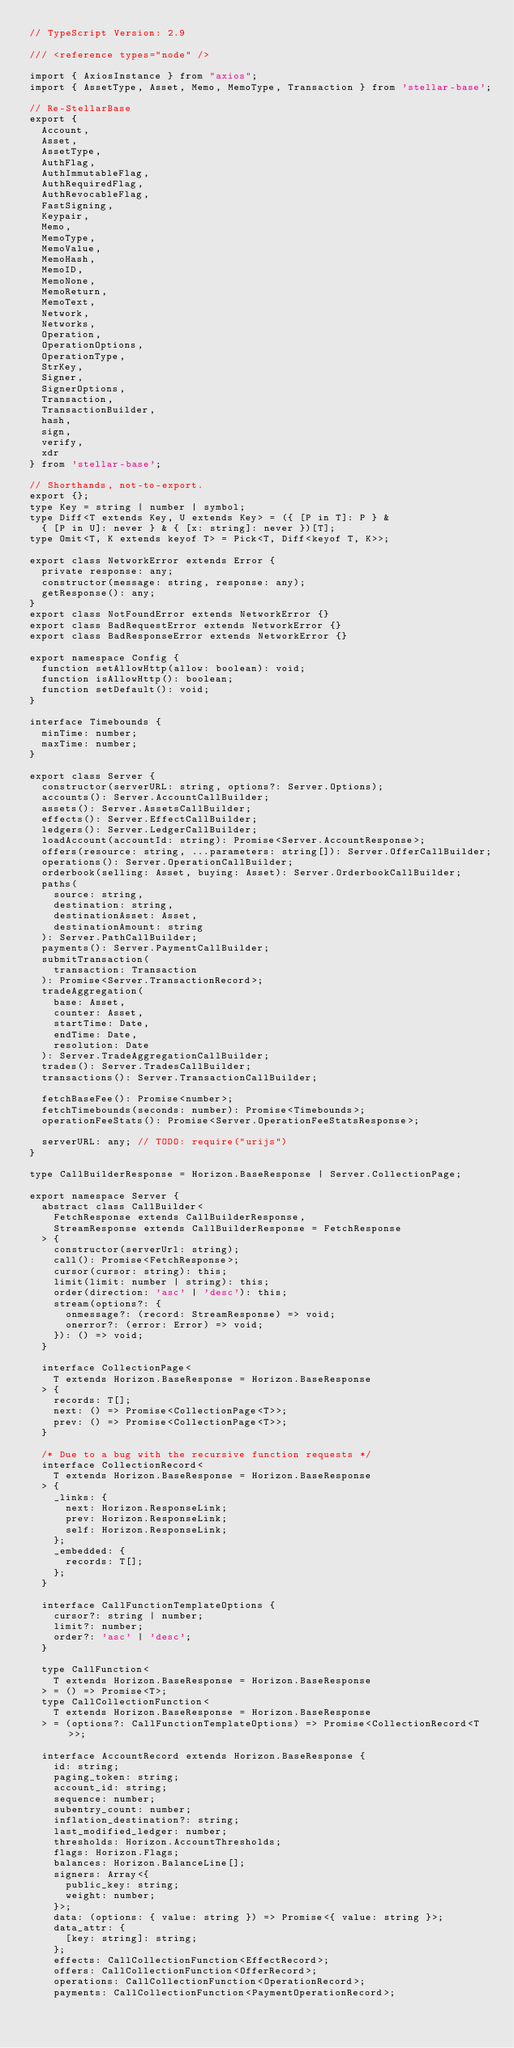Convert code to text. <code><loc_0><loc_0><loc_500><loc_500><_TypeScript_>// TypeScript Version: 2.9

/// <reference types="node" />

import { AxiosInstance } from "axios";
import { AssetType, Asset, Memo, MemoType, Transaction } from 'stellar-base';

// Re-StellarBase
export {
  Account,
  Asset,
  AssetType,
  AuthFlag,
  AuthImmutableFlag,
  AuthRequiredFlag,
  AuthRevocableFlag,
  FastSigning,
  Keypair,
  Memo,
  MemoType,
  MemoValue,
  MemoHash,
  MemoID,
  MemoNone,
  MemoReturn,
  MemoText,
  Network,
  Networks,
  Operation,
  OperationOptions,
  OperationType,
  StrKey,
  Signer,
  SignerOptions,
  Transaction,
  TransactionBuilder,
  hash,
  sign,
  verify,
  xdr
} from 'stellar-base';

// Shorthands, not-to-export.
export {};
type Key = string | number | symbol;
type Diff<T extends Key, U extends Key> = ({ [P in T]: P } &
  { [P in U]: never } & { [x: string]: never })[T];
type Omit<T, K extends keyof T> = Pick<T, Diff<keyof T, K>>;

export class NetworkError extends Error {
  private response: any;
  constructor(message: string, response: any);
  getResponse(): any;
}
export class NotFoundError extends NetworkError {}
export class BadRequestError extends NetworkError {}
export class BadResponseError extends NetworkError {}

export namespace Config {
  function setAllowHttp(allow: boolean): void;
  function isAllowHttp(): boolean;
  function setDefault(): void;
}

interface Timebounds {
  minTime: number;
  maxTime: number;
}

export class Server {
  constructor(serverURL: string, options?: Server.Options);
  accounts(): Server.AccountCallBuilder;
  assets(): Server.AssetsCallBuilder;
  effects(): Server.EffectCallBuilder;
  ledgers(): Server.LedgerCallBuilder;
  loadAccount(accountId: string): Promise<Server.AccountResponse>;
  offers(resource: string, ...parameters: string[]): Server.OfferCallBuilder;
  operations(): Server.OperationCallBuilder;
  orderbook(selling: Asset, buying: Asset): Server.OrderbookCallBuilder;
  paths(
    source: string,
    destination: string,
    destinationAsset: Asset,
    destinationAmount: string
  ): Server.PathCallBuilder;
  payments(): Server.PaymentCallBuilder;
  submitTransaction(
    transaction: Transaction
  ): Promise<Server.TransactionRecord>;
  tradeAggregation(
    base: Asset,
    counter: Asset,
    startTime: Date,
    endTime: Date,
    resolution: Date
  ): Server.TradeAggregationCallBuilder;
  trades(): Server.TradesCallBuilder;
  transactions(): Server.TransactionCallBuilder;

  fetchBaseFee(): Promise<number>;
  fetchTimebounds(seconds: number): Promise<Timebounds>;
  operationFeeStats(): Promise<Server.OperationFeeStatsResponse>;

  serverURL: any; // TODO: require("urijs")
}

type CallBuilderResponse = Horizon.BaseResponse | Server.CollectionPage;

export namespace Server {
  abstract class CallBuilder<
    FetchResponse extends CallBuilderResponse,
    StreamResponse extends CallBuilderResponse = FetchResponse
  > {
    constructor(serverUrl: string);
    call(): Promise<FetchResponse>;
    cursor(cursor: string): this;
    limit(limit: number | string): this;
    order(direction: 'asc' | 'desc'): this;
    stream(options?: {
      onmessage?: (record: StreamResponse) => void;
      onerror?: (error: Error) => void;
    }): () => void;
  }

  interface CollectionPage<
    T extends Horizon.BaseResponse = Horizon.BaseResponse
  > {
    records: T[];
    next: () => Promise<CollectionPage<T>>;
    prev: () => Promise<CollectionPage<T>>;
  }

  /* Due to a bug with the recursive function requests */
  interface CollectionRecord<
    T extends Horizon.BaseResponse = Horizon.BaseResponse
  > {
    _links: {
      next: Horizon.ResponseLink;
      prev: Horizon.ResponseLink;
      self: Horizon.ResponseLink;
    };
    _embedded: {
      records: T[];
    };
  }

  interface CallFunctionTemplateOptions {
    cursor?: string | number;
    limit?: number;
    order?: 'asc' | 'desc';
  }

  type CallFunction<
    T extends Horizon.BaseResponse = Horizon.BaseResponse
  > = () => Promise<T>;
  type CallCollectionFunction<
    T extends Horizon.BaseResponse = Horizon.BaseResponse
  > = (options?: CallFunctionTemplateOptions) => Promise<CollectionRecord<T>>;

  interface AccountRecord extends Horizon.BaseResponse {
    id: string;
    paging_token: string;
    account_id: string;
    sequence: number;
    subentry_count: number;
    inflation_destination?: string;
    last_modified_ledger: number;
    thresholds: Horizon.AccountThresholds;
    flags: Horizon.Flags;
    balances: Horizon.BalanceLine[];
    signers: Array<{
      public_key: string;
      weight: number;
    }>;
    data: (options: { value: string }) => Promise<{ value: string }>;
    data_attr: {
      [key: string]: string;
    };
    effects: CallCollectionFunction<EffectRecord>;
    offers: CallCollectionFunction<OfferRecord>;
    operations: CallCollectionFunction<OperationRecord>;
    payments: CallCollectionFunction<PaymentOperationRecord>;</code> 